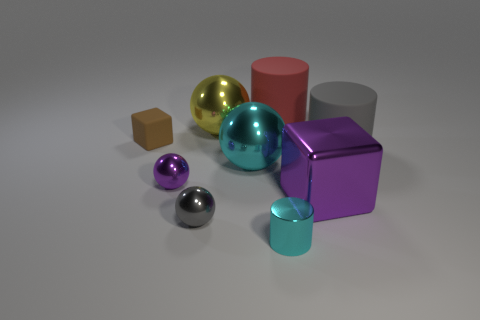Add 1 large purple cubes. How many objects exist? 10 Subtract all cylinders. How many objects are left? 6 Add 6 tiny gray metallic balls. How many tiny gray metallic balls are left? 7 Add 4 large purple shiny blocks. How many large purple shiny blocks exist? 5 Subtract 0 blue blocks. How many objects are left? 9 Subtract all brown blocks. Subtract all large purple metallic objects. How many objects are left? 7 